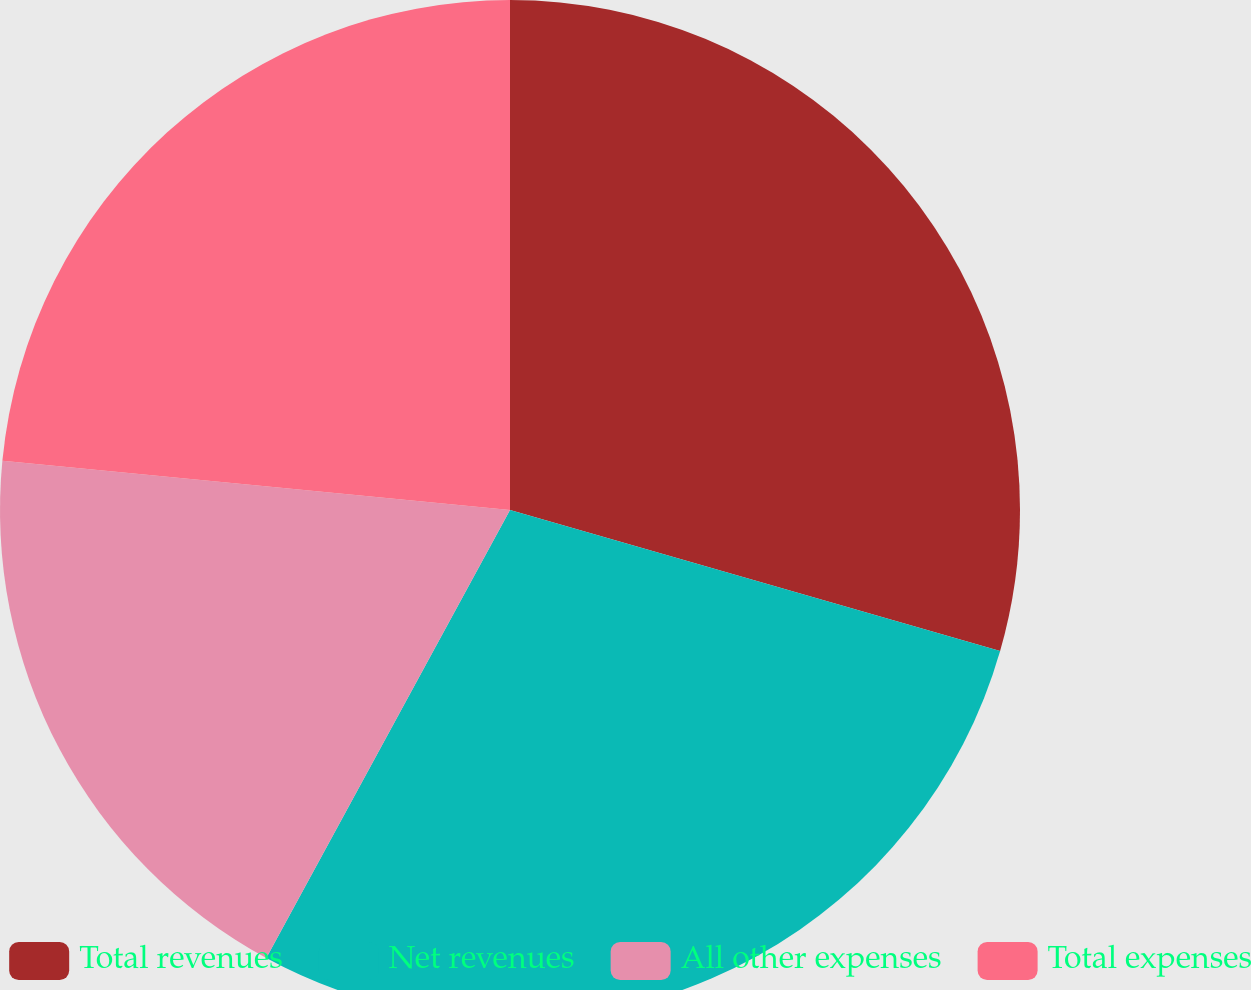Convert chart. <chart><loc_0><loc_0><loc_500><loc_500><pie_chart><fcel>Total revenues<fcel>Net revenues<fcel>All other expenses<fcel>Total expenses<nl><fcel>29.46%<fcel>28.47%<fcel>18.61%<fcel>23.46%<nl></chart> 